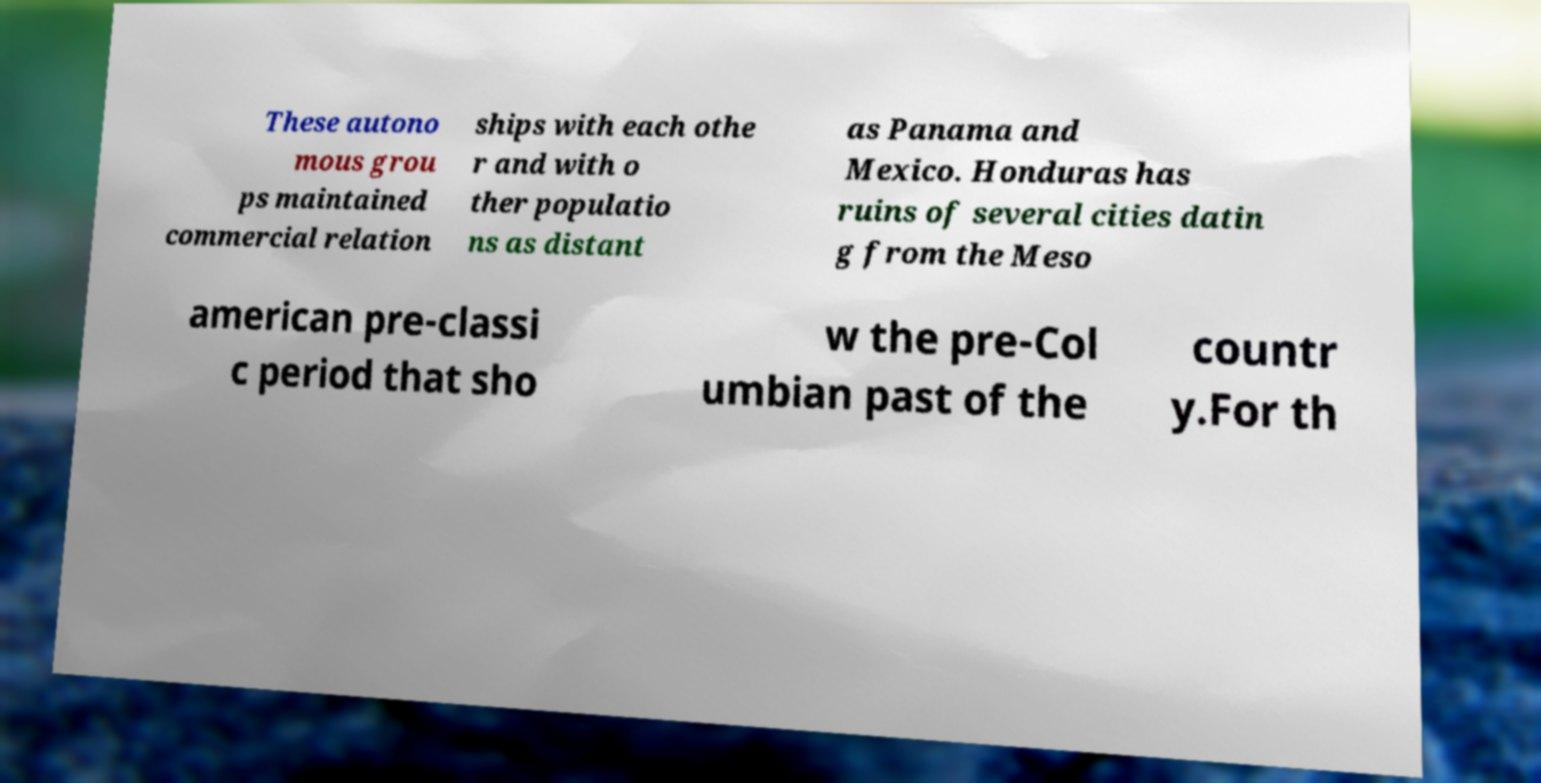Could you extract and type out the text from this image? These autono mous grou ps maintained commercial relation ships with each othe r and with o ther populatio ns as distant as Panama and Mexico. Honduras has ruins of several cities datin g from the Meso american pre-classi c period that sho w the pre-Col umbian past of the countr y.For th 